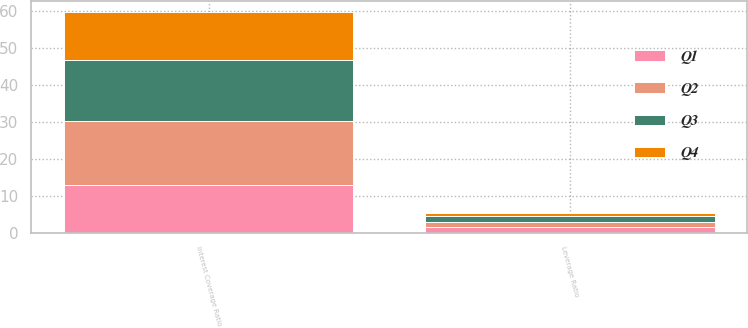Convert chart. <chart><loc_0><loc_0><loc_500><loc_500><stacked_bar_chart><ecel><fcel>Leverage Ratio<fcel>Interest Coverage Ratio<nl><fcel>Q4<fcel>0.99<fcel>13.06<nl><fcel>Q1<fcel>1.6<fcel>13.03<nl><fcel>Q3<fcel>1.52<fcel>16.43<nl><fcel>Q2<fcel>1.34<fcel>17.26<nl></chart> 